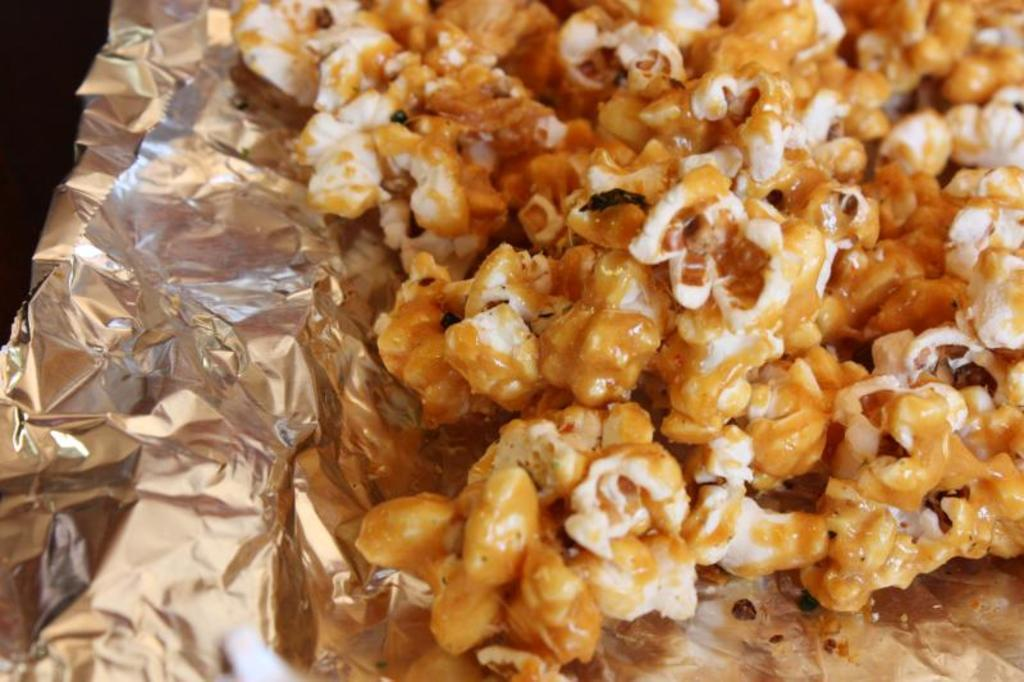What type of food can be seen in the image? There are popcorns in the image. How are the popcorns arranged or presented? The popcorns are on foil paper. What type of celery is being twisted in the middle of the image? There is no celery present in the image. How many times is the celery twisted in the middle of the image? Since there is no celery in the image, it cannot be twisted or have any specific number of twists. 